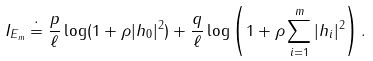Convert formula to latex. <formula><loc_0><loc_0><loc_500><loc_500>I _ { E _ { m } } \doteq \frac { p } { \ell } \log ( 1 + \rho | h _ { 0 } | ^ { 2 } ) + \frac { q } { \ell } \log \left ( 1 + \rho \sum _ { i = 1 } ^ { m } | h _ { i } | ^ { 2 } \right ) .</formula> 